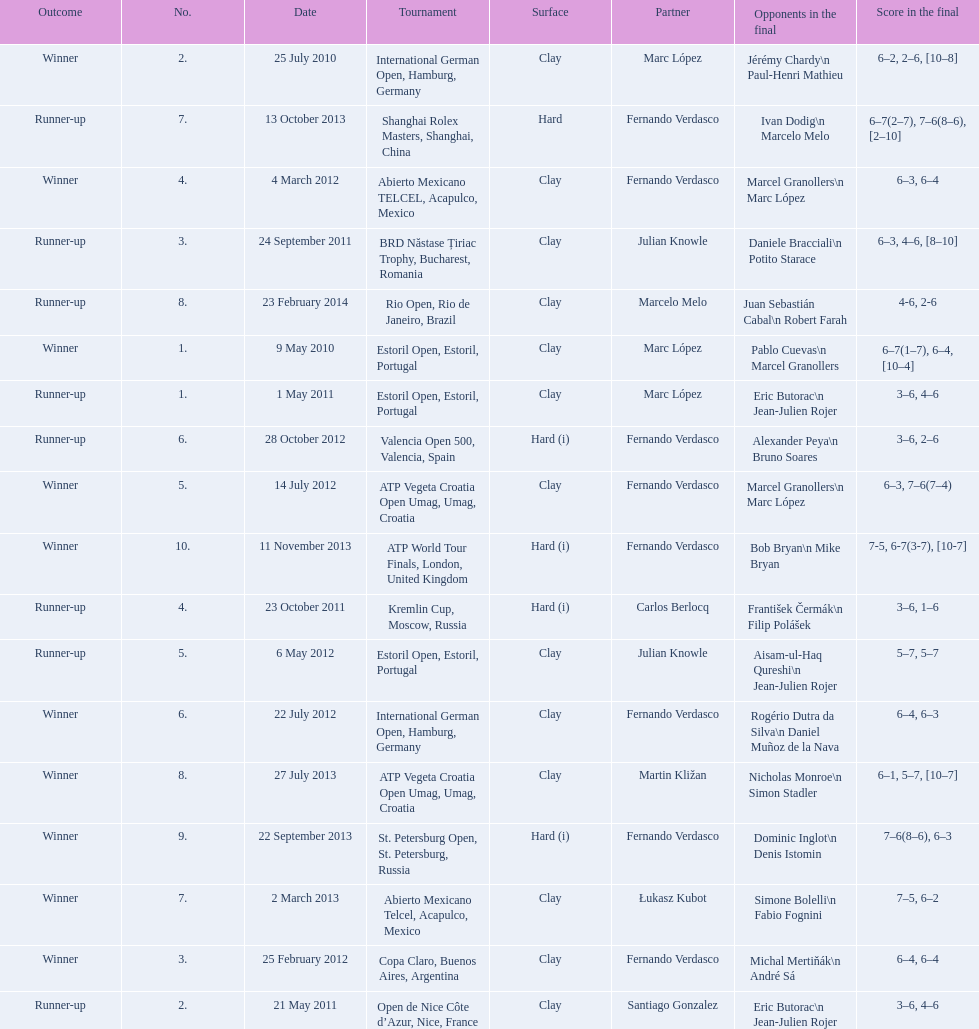How many runner-ups at most are listed? 8. Help me parse the entirety of this table. {'header': ['Outcome', 'No.', 'Date', 'Tournament', 'Surface', 'Partner', 'Opponents in the final', 'Score in the final'], 'rows': [['Winner', '2.', '25 July 2010', 'International German Open, Hamburg, Germany', 'Clay', 'Marc López', 'Jérémy Chardy\\n Paul-Henri Mathieu', '6–2, 2–6, [10–8]'], ['Runner-up', '7.', '13 October 2013', 'Shanghai Rolex Masters, Shanghai, China', 'Hard', 'Fernando Verdasco', 'Ivan Dodig\\n Marcelo Melo', '6–7(2–7), 7–6(8–6), [2–10]'], ['Winner', '4.', '4 March 2012', 'Abierto Mexicano TELCEL, Acapulco, Mexico', 'Clay', 'Fernando Verdasco', 'Marcel Granollers\\n Marc López', '6–3, 6–4'], ['Runner-up', '3.', '24 September 2011', 'BRD Năstase Țiriac Trophy, Bucharest, Romania', 'Clay', 'Julian Knowle', 'Daniele Bracciali\\n Potito Starace', '6–3, 4–6, [8–10]'], ['Runner-up', '8.', '23 February 2014', 'Rio Open, Rio de Janeiro, Brazil', 'Clay', 'Marcelo Melo', 'Juan Sebastián Cabal\\n Robert Farah', '4-6, 2-6'], ['Winner', '1.', '9 May 2010', 'Estoril Open, Estoril, Portugal', 'Clay', 'Marc López', 'Pablo Cuevas\\n Marcel Granollers', '6–7(1–7), 6–4, [10–4]'], ['Runner-up', '1.', '1 May 2011', 'Estoril Open, Estoril, Portugal', 'Clay', 'Marc López', 'Eric Butorac\\n Jean-Julien Rojer', '3–6, 4–6'], ['Runner-up', '6.', '28 October 2012', 'Valencia Open 500, Valencia, Spain', 'Hard (i)', 'Fernando Verdasco', 'Alexander Peya\\n Bruno Soares', '3–6, 2–6'], ['Winner', '5.', '14 July 2012', 'ATP Vegeta Croatia Open Umag, Umag, Croatia', 'Clay', 'Fernando Verdasco', 'Marcel Granollers\\n Marc López', '6–3, 7–6(7–4)'], ['Winner', '10.', '11 November 2013', 'ATP World Tour Finals, London, United Kingdom', 'Hard (i)', 'Fernando Verdasco', 'Bob Bryan\\n Mike Bryan', '7-5, 6-7(3-7), [10-7]'], ['Runner-up', '4.', '23 October 2011', 'Kremlin Cup, Moscow, Russia', 'Hard (i)', 'Carlos Berlocq', 'František Čermák\\n Filip Polášek', '3–6, 1–6'], ['Runner-up', '5.', '6 May 2012', 'Estoril Open, Estoril, Portugal', 'Clay', 'Julian Knowle', 'Aisam-ul-Haq Qureshi\\n Jean-Julien Rojer', '5–7, 5–7'], ['Winner', '6.', '22 July 2012', 'International German Open, Hamburg, Germany', 'Clay', 'Fernando Verdasco', 'Rogério Dutra da Silva\\n Daniel Muñoz de la Nava', '6–4, 6–3'], ['Winner', '8.', '27 July 2013', 'ATP Vegeta Croatia Open Umag, Umag, Croatia', 'Clay', 'Martin Kližan', 'Nicholas Monroe\\n Simon Stadler', '6–1, 5–7, [10–7]'], ['Winner', '9.', '22 September 2013', 'St. Petersburg Open, St. Petersburg, Russia', 'Hard (i)', 'Fernando Verdasco', 'Dominic Inglot\\n Denis Istomin', '7–6(8–6), 6–3'], ['Winner', '7.', '2 March 2013', 'Abierto Mexicano Telcel, Acapulco, Mexico', 'Clay', 'Łukasz Kubot', 'Simone Bolelli\\n Fabio Fognini', '7–5, 6–2'], ['Winner', '3.', '25 February 2012', 'Copa Claro, Buenos Aires, Argentina', 'Clay', 'Fernando Verdasco', 'Michal Mertiňák\\n André Sá', '6–4, 6–4'], ['Runner-up', '2.', '21 May 2011', 'Open de Nice Côte d’Azur, Nice, France', 'Clay', 'Santiago Gonzalez', 'Eric Butorac\\n Jean-Julien Rojer', '3–6, 4–6']]} 